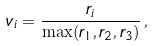<formula> <loc_0><loc_0><loc_500><loc_500>v _ { i } = \frac { r _ { i } } { \max ( r _ { 1 } , r _ { 2 } , r _ { 3 } ) } \, ,</formula> 